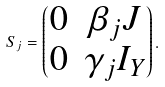Convert formula to latex. <formula><loc_0><loc_0><loc_500><loc_500>S _ { j } = \begin{pmatrix} 0 & \beta _ { j } J \\ 0 & \gamma _ { j } I _ { Y } \end{pmatrix} .</formula> 